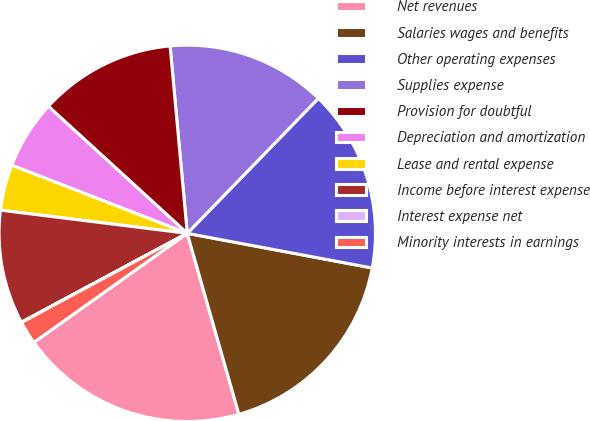Convert chart. <chart><loc_0><loc_0><loc_500><loc_500><pie_chart><fcel>Net revenues<fcel>Salaries wages and benefits<fcel>Other operating expenses<fcel>Supplies expense<fcel>Provision for doubtful<fcel>Depreciation and amortization<fcel>Lease and rental expense<fcel>Income before interest expense<fcel>Interest expense net<fcel>Minority interests in earnings<nl><fcel>19.59%<fcel>17.63%<fcel>15.68%<fcel>13.72%<fcel>11.76%<fcel>5.89%<fcel>3.93%<fcel>9.8%<fcel>0.02%<fcel>1.98%<nl></chart> 